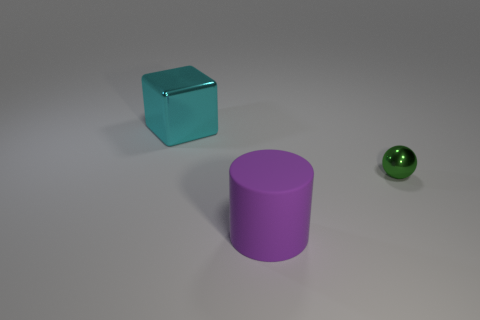Add 1 large purple rubber cylinders. How many objects exist? 4 Subtract all cubes. How many objects are left? 2 Subtract 0 green cylinders. How many objects are left? 3 Subtract all big purple cylinders. Subtract all metal blocks. How many objects are left? 1 Add 3 small balls. How many small balls are left? 4 Add 2 brown metallic spheres. How many brown metallic spheres exist? 2 